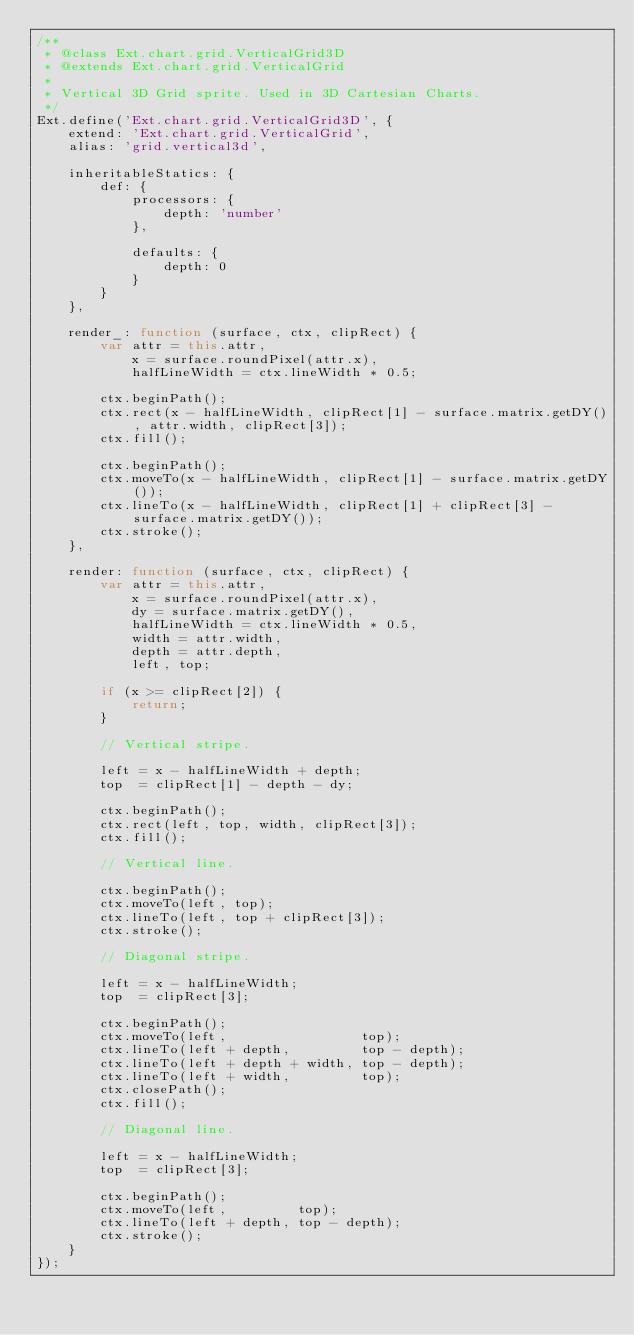<code> <loc_0><loc_0><loc_500><loc_500><_JavaScript_>/**
 * @class Ext.chart.grid.VerticalGrid3D
 * @extends Ext.chart.grid.VerticalGrid
 * 
 * Vertical 3D Grid sprite. Used in 3D Cartesian Charts.
 */
Ext.define('Ext.chart.grid.VerticalGrid3D', {
    extend: 'Ext.chart.grid.VerticalGrid',
    alias: 'grid.vertical3d',

    inheritableStatics: {
        def: {
            processors: {
                depth: 'number'
            },

            defaults: {
                depth: 0
            }
        }
    },

    render_: function (surface, ctx, clipRect) {
        var attr = this.attr,
            x = surface.roundPixel(attr.x),
            halfLineWidth = ctx.lineWidth * 0.5;

        ctx.beginPath();
        ctx.rect(x - halfLineWidth, clipRect[1] - surface.matrix.getDY(), attr.width, clipRect[3]);
        ctx.fill();

        ctx.beginPath();
        ctx.moveTo(x - halfLineWidth, clipRect[1] - surface.matrix.getDY());
        ctx.lineTo(x - halfLineWidth, clipRect[1] + clipRect[3] - surface.matrix.getDY());
        ctx.stroke();
    },

    render: function (surface, ctx, clipRect) {
        var attr = this.attr,
            x = surface.roundPixel(attr.x),
            dy = surface.matrix.getDY(),
            halfLineWidth = ctx.lineWidth * 0.5,
            width = attr.width,
            depth = attr.depth,
            left, top;

        if (x >= clipRect[2]) {
            return;
        }

        // Vertical stripe.

        left = x - halfLineWidth + depth;
        top  = clipRect[1] - depth - dy;

        ctx.beginPath();
        ctx.rect(left, top, width, clipRect[3]);
        ctx.fill();

        // Vertical line.

        ctx.beginPath();
        ctx.moveTo(left, top);
        ctx.lineTo(left, top + clipRect[3]);
        ctx.stroke();

        // Diagonal stripe.

        left = x - halfLineWidth;
        top  = clipRect[3];

        ctx.beginPath();
        ctx.moveTo(left,                 top);
        ctx.lineTo(left + depth,         top - depth);
        ctx.lineTo(left + depth + width, top - depth);
        ctx.lineTo(left + width,         top);
        ctx.closePath();
        ctx.fill();

        // Diagonal line.

        left = x - halfLineWidth;
        top  = clipRect[3];

        ctx.beginPath();
        ctx.moveTo(left,         top);
        ctx.lineTo(left + depth, top - depth);
        ctx.stroke();
    }
});</code> 